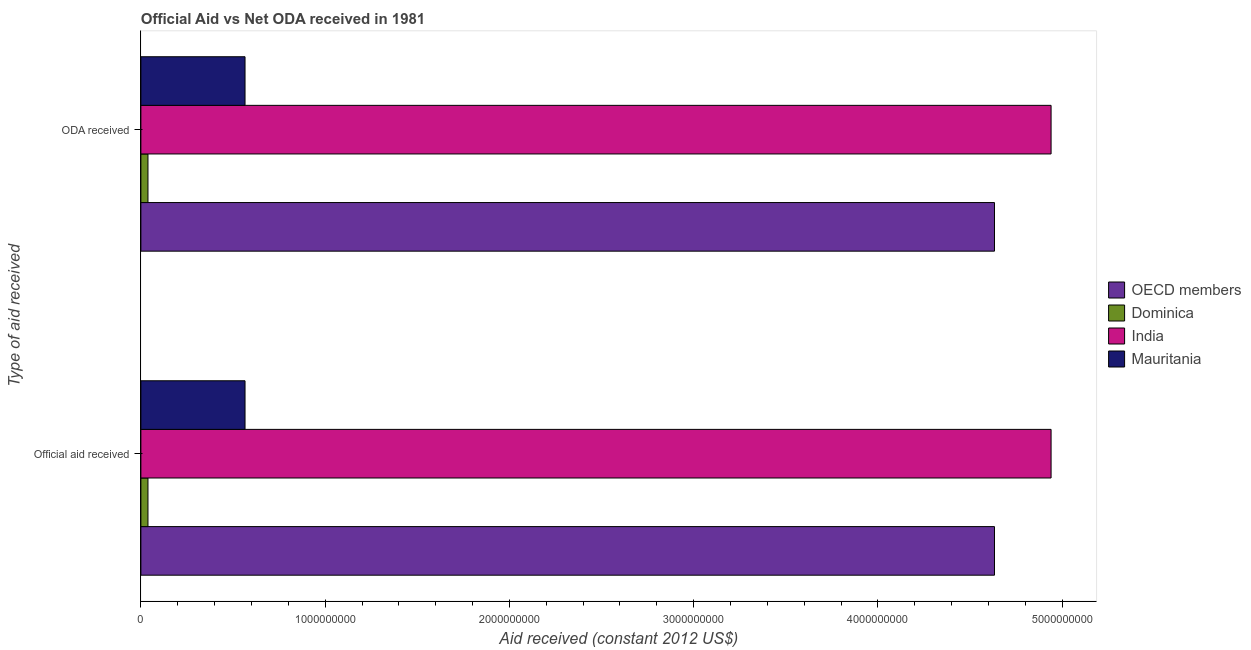How many different coloured bars are there?
Your response must be concise. 4. How many groups of bars are there?
Offer a terse response. 2. How many bars are there on the 1st tick from the bottom?
Provide a succinct answer. 4. What is the label of the 1st group of bars from the top?
Make the answer very short. ODA received. What is the oda received in Dominica?
Make the answer very short. 3.84e+07. Across all countries, what is the maximum official aid received?
Your answer should be very brief. 4.94e+09. Across all countries, what is the minimum official aid received?
Offer a terse response. 3.84e+07. In which country was the oda received maximum?
Make the answer very short. India. In which country was the official aid received minimum?
Offer a terse response. Dominica. What is the total oda received in the graph?
Give a very brief answer. 1.02e+1. What is the difference between the official aid received in India and that in Mauritania?
Ensure brevity in your answer.  4.37e+09. What is the difference between the official aid received in Dominica and the oda received in OECD members?
Your response must be concise. -4.59e+09. What is the average oda received per country?
Your answer should be very brief. 2.54e+09. In how many countries, is the oda received greater than 4200000000 US$?
Provide a short and direct response. 2. What is the ratio of the official aid received in Mauritania to that in India?
Ensure brevity in your answer.  0.11. What does the 1st bar from the top in ODA received represents?
Your answer should be very brief. Mauritania. How many bars are there?
Provide a short and direct response. 8. Are all the bars in the graph horizontal?
Ensure brevity in your answer.  Yes. How many countries are there in the graph?
Keep it short and to the point. 4. What is the difference between two consecutive major ticks on the X-axis?
Provide a succinct answer. 1.00e+09. Does the graph contain any zero values?
Keep it short and to the point. No. Where does the legend appear in the graph?
Give a very brief answer. Center right. How are the legend labels stacked?
Give a very brief answer. Vertical. What is the title of the graph?
Provide a succinct answer. Official Aid vs Net ODA received in 1981 . Does "American Samoa" appear as one of the legend labels in the graph?
Provide a succinct answer. No. What is the label or title of the X-axis?
Ensure brevity in your answer.  Aid received (constant 2012 US$). What is the label or title of the Y-axis?
Your response must be concise. Type of aid received. What is the Aid received (constant 2012 US$) in OECD members in Official aid received?
Your answer should be very brief. 4.63e+09. What is the Aid received (constant 2012 US$) in Dominica in Official aid received?
Your answer should be very brief. 3.84e+07. What is the Aid received (constant 2012 US$) in India in Official aid received?
Your answer should be compact. 4.94e+09. What is the Aid received (constant 2012 US$) of Mauritania in Official aid received?
Keep it short and to the point. 5.65e+08. What is the Aid received (constant 2012 US$) in OECD members in ODA received?
Provide a succinct answer. 4.63e+09. What is the Aid received (constant 2012 US$) in Dominica in ODA received?
Ensure brevity in your answer.  3.84e+07. What is the Aid received (constant 2012 US$) in India in ODA received?
Ensure brevity in your answer.  4.94e+09. What is the Aid received (constant 2012 US$) in Mauritania in ODA received?
Your answer should be very brief. 5.65e+08. Across all Type of aid received, what is the maximum Aid received (constant 2012 US$) in OECD members?
Keep it short and to the point. 4.63e+09. Across all Type of aid received, what is the maximum Aid received (constant 2012 US$) in Dominica?
Make the answer very short. 3.84e+07. Across all Type of aid received, what is the maximum Aid received (constant 2012 US$) in India?
Your response must be concise. 4.94e+09. Across all Type of aid received, what is the maximum Aid received (constant 2012 US$) of Mauritania?
Your response must be concise. 5.65e+08. Across all Type of aid received, what is the minimum Aid received (constant 2012 US$) of OECD members?
Your answer should be very brief. 4.63e+09. Across all Type of aid received, what is the minimum Aid received (constant 2012 US$) of Dominica?
Your response must be concise. 3.84e+07. Across all Type of aid received, what is the minimum Aid received (constant 2012 US$) of India?
Your answer should be compact. 4.94e+09. Across all Type of aid received, what is the minimum Aid received (constant 2012 US$) of Mauritania?
Give a very brief answer. 5.65e+08. What is the total Aid received (constant 2012 US$) in OECD members in the graph?
Keep it short and to the point. 9.27e+09. What is the total Aid received (constant 2012 US$) in Dominica in the graph?
Provide a succinct answer. 7.69e+07. What is the total Aid received (constant 2012 US$) of India in the graph?
Your answer should be compact. 9.88e+09. What is the total Aid received (constant 2012 US$) of Mauritania in the graph?
Offer a terse response. 1.13e+09. What is the difference between the Aid received (constant 2012 US$) in India in Official aid received and that in ODA received?
Your answer should be compact. 0. What is the difference between the Aid received (constant 2012 US$) in Mauritania in Official aid received and that in ODA received?
Your response must be concise. 0. What is the difference between the Aid received (constant 2012 US$) in OECD members in Official aid received and the Aid received (constant 2012 US$) in Dominica in ODA received?
Your response must be concise. 4.59e+09. What is the difference between the Aid received (constant 2012 US$) of OECD members in Official aid received and the Aid received (constant 2012 US$) of India in ODA received?
Give a very brief answer. -3.07e+08. What is the difference between the Aid received (constant 2012 US$) in OECD members in Official aid received and the Aid received (constant 2012 US$) in Mauritania in ODA received?
Offer a very short reply. 4.07e+09. What is the difference between the Aid received (constant 2012 US$) in Dominica in Official aid received and the Aid received (constant 2012 US$) in India in ODA received?
Offer a terse response. -4.90e+09. What is the difference between the Aid received (constant 2012 US$) of Dominica in Official aid received and the Aid received (constant 2012 US$) of Mauritania in ODA received?
Your answer should be compact. -5.27e+08. What is the difference between the Aid received (constant 2012 US$) in India in Official aid received and the Aid received (constant 2012 US$) in Mauritania in ODA received?
Keep it short and to the point. 4.37e+09. What is the average Aid received (constant 2012 US$) of OECD members per Type of aid received?
Offer a very short reply. 4.63e+09. What is the average Aid received (constant 2012 US$) in Dominica per Type of aid received?
Give a very brief answer. 3.84e+07. What is the average Aid received (constant 2012 US$) of India per Type of aid received?
Offer a terse response. 4.94e+09. What is the average Aid received (constant 2012 US$) in Mauritania per Type of aid received?
Offer a terse response. 5.65e+08. What is the difference between the Aid received (constant 2012 US$) in OECD members and Aid received (constant 2012 US$) in Dominica in Official aid received?
Offer a terse response. 4.59e+09. What is the difference between the Aid received (constant 2012 US$) in OECD members and Aid received (constant 2012 US$) in India in Official aid received?
Ensure brevity in your answer.  -3.07e+08. What is the difference between the Aid received (constant 2012 US$) of OECD members and Aid received (constant 2012 US$) of Mauritania in Official aid received?
Your answer should be compact. 4.07e+09. What is the difference between the Aid received (constant 2012 US$) of Dominica and Aid received (constant 2012 US$) of India in Official aid received?
Keep it short and to the point. -4.90e+09. What is the difference between the Aid received (constant 2012 US$) of Dominica and Aid received (constant 2012 US$) of Mauritania in Official aid received?
Give a very brief answer. -5.27e+08. What is the difference between the Aid received (constant 2012 US$) of India and Aid received (constant 2012 US$) of Mauritania in Official aid received?
Your answer should be very brief. 4.37e+09. What is the difference between the Aid received (constant 2012 US$) of OECD members and Aid received (constant 2012 US$) of Dominica in ODA received?
Your response must be concise. 4.59e+09. What is the difference between the Aid received (constant 2012 US$) of OECD members and Aid received (constant 2012 US$) of India in ODA received?
Your response must be concise. -3.07e+08. What is the difference between the Aid received (constant 2012 US$) in OECD members and Aid received (constant 2012 US$) in Mauritania in ODA received?
Offer a terse response. 4.07e+09. What is the difference between the Aid received (constant 2012 US$) in Dominica and Aid received (constant 2012 US$) in India in ODA received?
Provide a short and direct response. -4.90e+09. What is the difference between the Aid received (constant 2012 US$) of Dominica and Aid received (constant 2012 US$) of Mauritania in ODA received?
Your answer should be compact. -5.27e+08. What is the difference between the Aid received (constant 2012 US$) in India and Aid received (constant 2012 US$) in Mauritania in ODA received?
Your response must be concise. 4.37e+09. What is the ratio of the Aid received (constant 2012 US$) of Dominica in Official aid received to that in ODA received?
Your answer should be compact. 1. What is the ratio of the Aid received (constant 2012 US$) in India in Official aid received to that in ODA received?
Ensure brevity in your answer.  1. What is the difference between the highest and the second highest Aid received (constant 2012 US$) of OECD members?
Your answer should be very brief. 0. What is the difference between the highest and the second highest Aid received (constant 2012 US$) of Dominica?
Your answer should be compact. 0. What is the difference between the highest and the second highest Aid received (constant 2012 US$) of India?
Offer a terse response. 0. What is the difference between the highest and the second highest Aid received (constant 2012 US$) of Mauritania?
Offer a very short reply. 0. What is the difference between the highest and the lowest Aid received (constant 2012 US$) in Dominica?
Your answer should be very brief. 0. What is the difference between the highest and the lowest Aid received (constant 2012 US$) of India?
Provide a succinct answer. 0. 